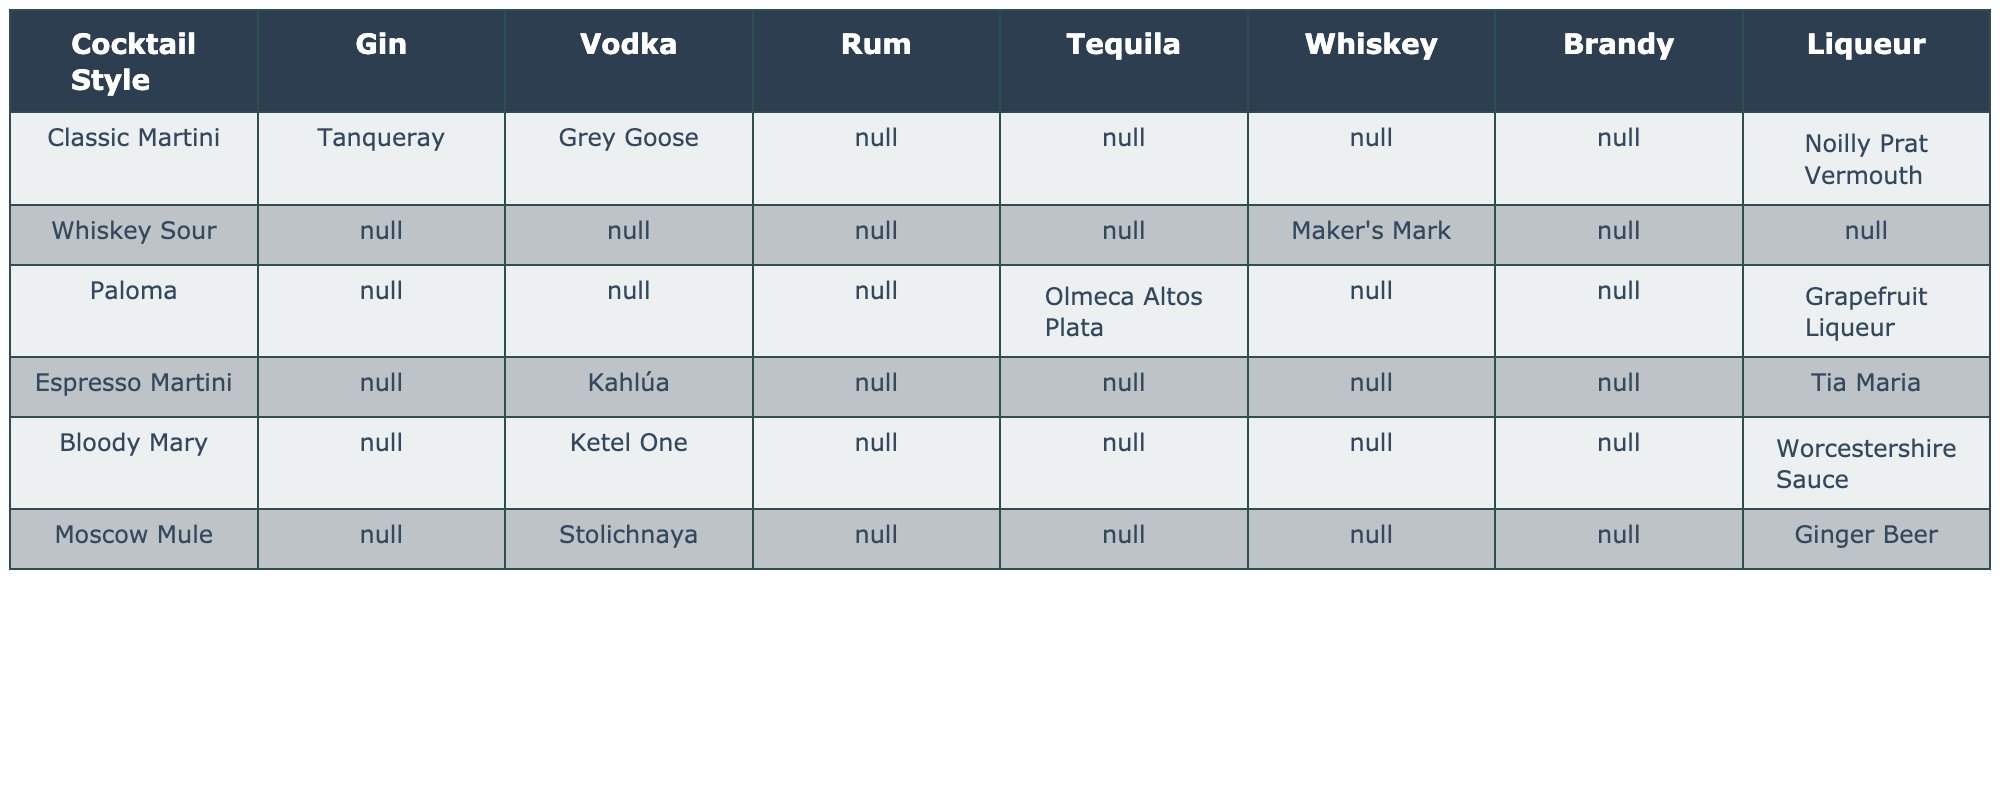What spirit is recommended for a Classic Martini? The table lists "Tanqueray" gin as the recommended spirit for a Classic Martini.
Answer: Tanqueray Which cocktail style pairs with Olmeca Altos Plata? According to the table, Olmeca Altos Plata is paired with the Paloma cocktail style.
Answer: Paloma Is there a whiskey pairing for the Paloma cocktail? The table does not list a whiskey pairing for the Paloma cocktail, indicating that none is recommended.
Answer: No Which liqueur is suggested for the Espresso Martini? The table shows "Tia Maria" as the suggested liqueur for the Espresso Martini.
Answer: Tia Maria How many different spirits are recommended for the Bloody Mary? The table indicates that only one spirit, "Ketel One" vodka, is paired with the Bloody Mary, making it a single recommendation.
Answer: 1 What cocktail style has both gin and liqueur recommendations? The Classic Martini has gin (Tanqueray) and a liqueur (Noilly Prat Vermouth) recommended, fulfilling the requirement for both.
Answer: Classic Martini How many types of spirits are suggested for the Whiskey Sour? The table lists only one type of spirit, which is Maker's Mark whiskey, for the Whiskey Sour.
Answer: 1 Which cocktail styles have no spirit recommendations listed? The table shows that the Whiskey Sour and Classic Martini are the only styles without specific spirit recommendations listed.
Answer: None Is there a tequila option paired with the Whiskey Sour cocktail? The table does not provide any tequila option for the Whiskey Sour, confirming that it is not included.
Answer: No Which cocktail style pairs with the Grapefruit Liqueur? The table indicates that the Paloma is the cocktail style that pairs with Grapefruit Liqueur.
Answer: Paloma What is the total number of unique spirit types recommended across all cocktail styles in the table? The unique spirit types include Gin, Vodka, Rum, Tequila, Whiskey, Brandy, and Liqueur, totaling seven distinct categories of spirits recommended.
Answer: 7 